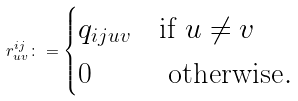<formula> <loc_0><loc_0><loc_500><loc_500>r ^ { i j } _ { u v } \colon = \begin{cases} q _ { i j u v } & \text {if } u \neq v \\ 0 & \text { otherwise} . \end{cases}</formula> 